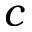Convert formula to latex. <formula><loc_0><loc_0><loc_500><loc_500>c</formula> 